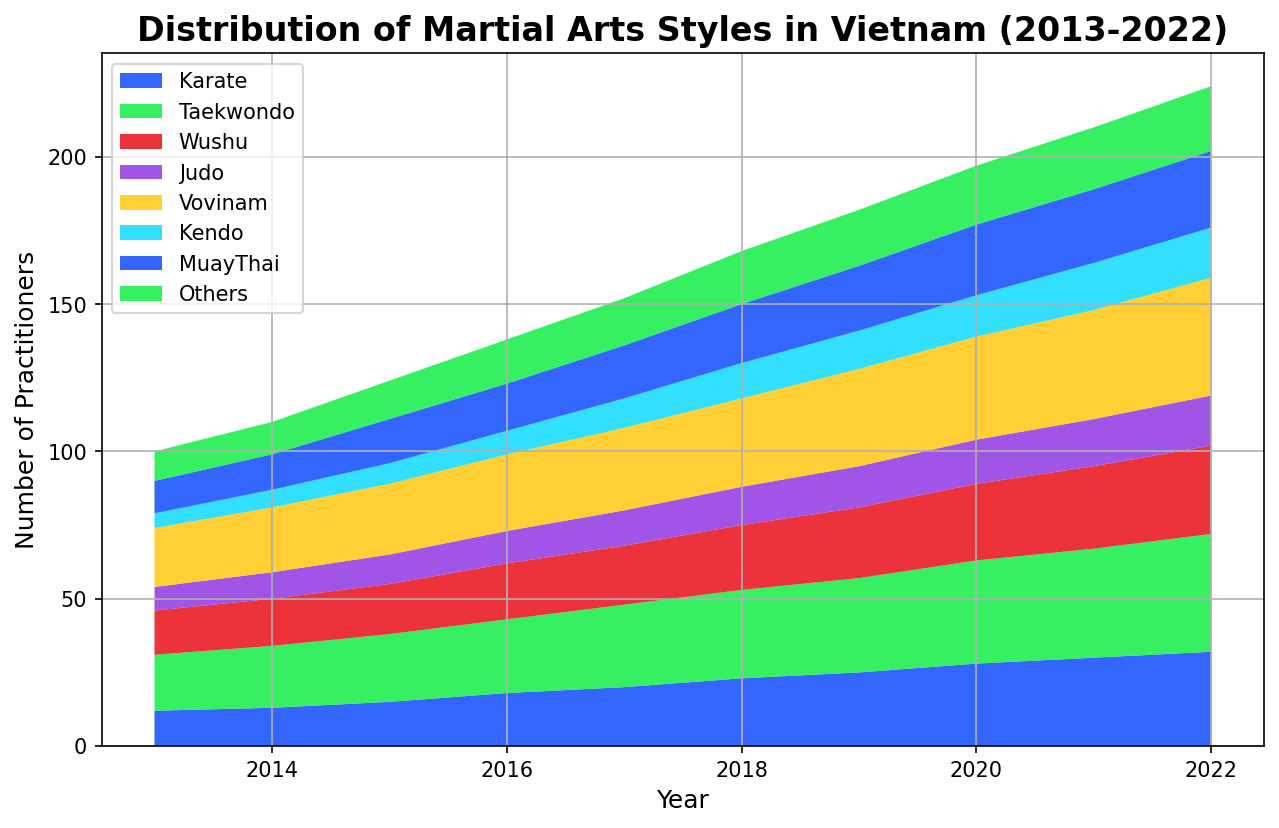Which martial art saw the largest growth in practitioners from 2013 to 2022? First, identify the values for each martial art in 2013 and 2022. Then, calculate the difference in practitioners for each. The martial art with the largest difference represents the largest growth.
Answer: Vovinam Among Karate and Judo, which had more practitioners in 2020? Check the value for Karate and Judo in 2020 on the chart, and compare them.
Answer: Karate By how much did Muay Thai practitioners increase from 2016 to 2019? Identify the number of Muay Thai practitioners in 2016 and in 2019. Then, subtract the 2016 value from the 2019 value.
Answer: 6 What was the approximate total number of practitioners for Taekwondo and Wushu in 2018? Locate the values for Taekwondo and Wushu for 2018, and then sum these two values.
Answer: 52 In which year did Kendo practitioners first reach double digits? Review Kendo's values year by year until it reaches a value of 10 or more for the first time.
Answer: 2017 Comparing 2014 and 2019, which year saw more overall practitioners for all martial arts combined? Sum the practitioners for all martial arts for both 2014 and 2019, then compare the totals.
Answer: 2019 Which martial art saw the smallest increase in practitioners from 2013 to 2017? Calculate the difference in practitioners for all martial arts from 2013 to 2017 and identify the smallest difference.
Answer: Judo What was the combined share of practitioners for Other styles and Kendo in 2022? Find the values for Others and Kendo in 2022 and add them together.
Answer: 39 Between Vovinam and Kendo, which martial art had more practitioners in 2019? Compare the 2019 values for Vovinam and Kendo.
Answer: Vovinam How many practitioners were there in total for all martial arts in 2013? Sum the values of all martial arts for the year 2013.
Answer: 100 